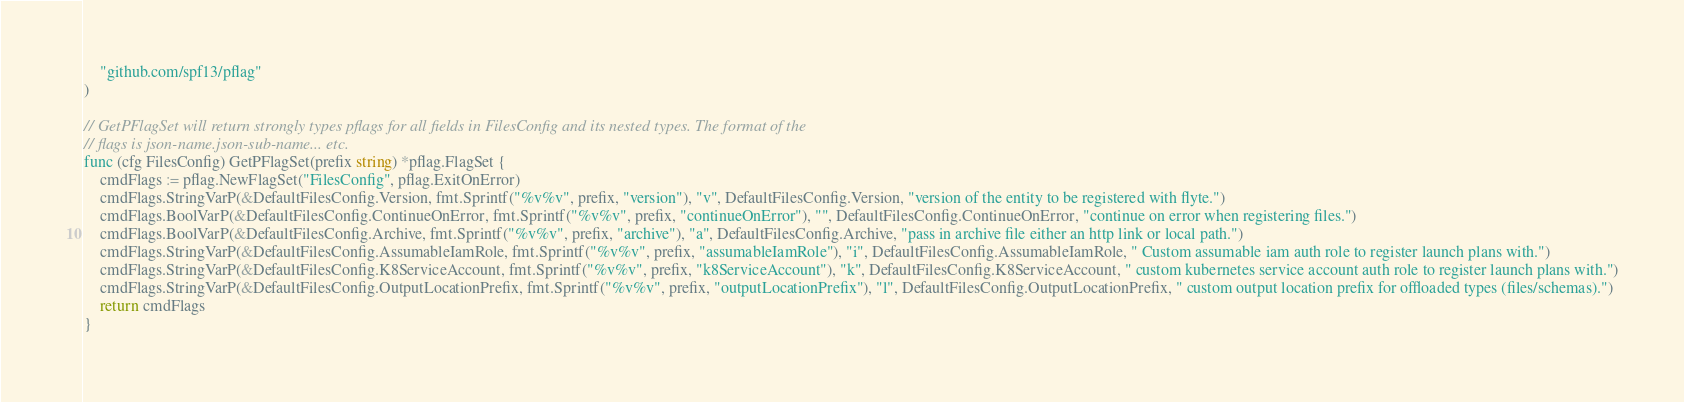<code> <loc_0><loc_0><loc_500><loc_500><_Go_>	"github.com/spf13/pflag"
)

// GetPFlagSet will return strongly types pflags for all fields in FilesConfig and its nested types. The format of the
// flags is json-name.json-sub-name... etc.
func (cfg FilesConfig) GetPFlagSet(prefix string) *pflag.FlagSet {
	cmdFlags := pflag.NewFlagSet("FilesConfig", pflag.ExitOnError)
	cmdFlags.StringVarP(&DefaultFilesConfig.Version, fmt.Sprintf("%v%v", prefix, "version"), "v", DefaultFilesConfig.Version, "version of the entity to be registered with flyte.")
	cmdFlags.BoolVarP(&DefaultFilesConfig.ContinueOnError, fmt.Sprintf("%v%v", prefix, "continueOnError"), "", DefaultFilesConfig.ContinueOnError, "continue on error when registering files.")
	cmdFlags.BoolVarP(&DefaultFilesConfig.Archive, fmt.Sprintf("%v%v", prefix, "archive"), "a", DefaultFilesConfig.Archive, "pass in archive file either an http link or local path.")
	cmdFlags.StringVarP(&DefaultFilesConfig.AssumableIamRole, fmt.Sprintf("%v%v", prefix, "assumableIamRole"), "i", DefaultFilesConfig.AssumableIamRole, " Custom assumable iam auth role to register launch plans with.")
	cmdFlags.StringVarP(&DefaultFilesConfig.K8ServiceAccount, fmt.Sprintf("%v%v", prefix, "k8ServiceAccount"), "k", DefaultFilesConfig.K8ServiceAccount, " custom kubernetes service account auth role to register launch plans with.")
	cmdFlags.StringVarP(&DefaultFilesConfig.OutputLocationPrefix, fmt.Sprintf("%v%v", prefix, "outputLocationPrefix"), "l", DefaultFilesConfig.OutputLocationPrefix, " custom output location prefix for offloaded types (files/schemas).")
	return cmdFlags
}
</code> 